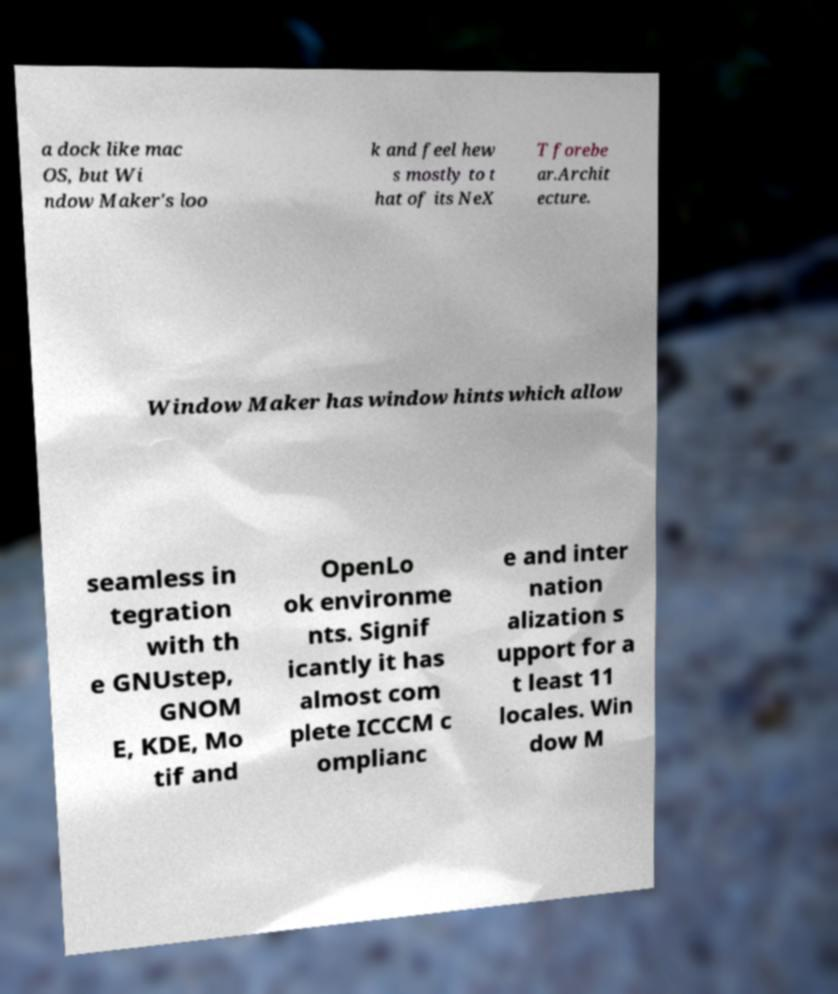Can you read and provide the text displayed in the image?This photo seems to have some interesting text. Can you extract and type it out for me? a dock like mac OS, but Wi ndow Maker's loo k and feel hew s mostly to t hat of its NeX T forebe ar.Archit ecture. Window Maker has window hints which allow seamless in tegration with th e GNUstep, GNOM E, KDE, Mo tif and OpenLo ok environme nts. Signif icantly it has almost com plete ICCCM c omplianc e and inter nation alization s upport for a t least 11 locales. Win dow M 